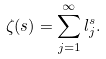Convert formula to latex. <formula><loc_0><loc_0><loc_500><loc_500>\zeta _ { \L } ( s ) = \sum _ { j = 1 } ^ { \infty } l _ { j } ^ { s } .</formula> 